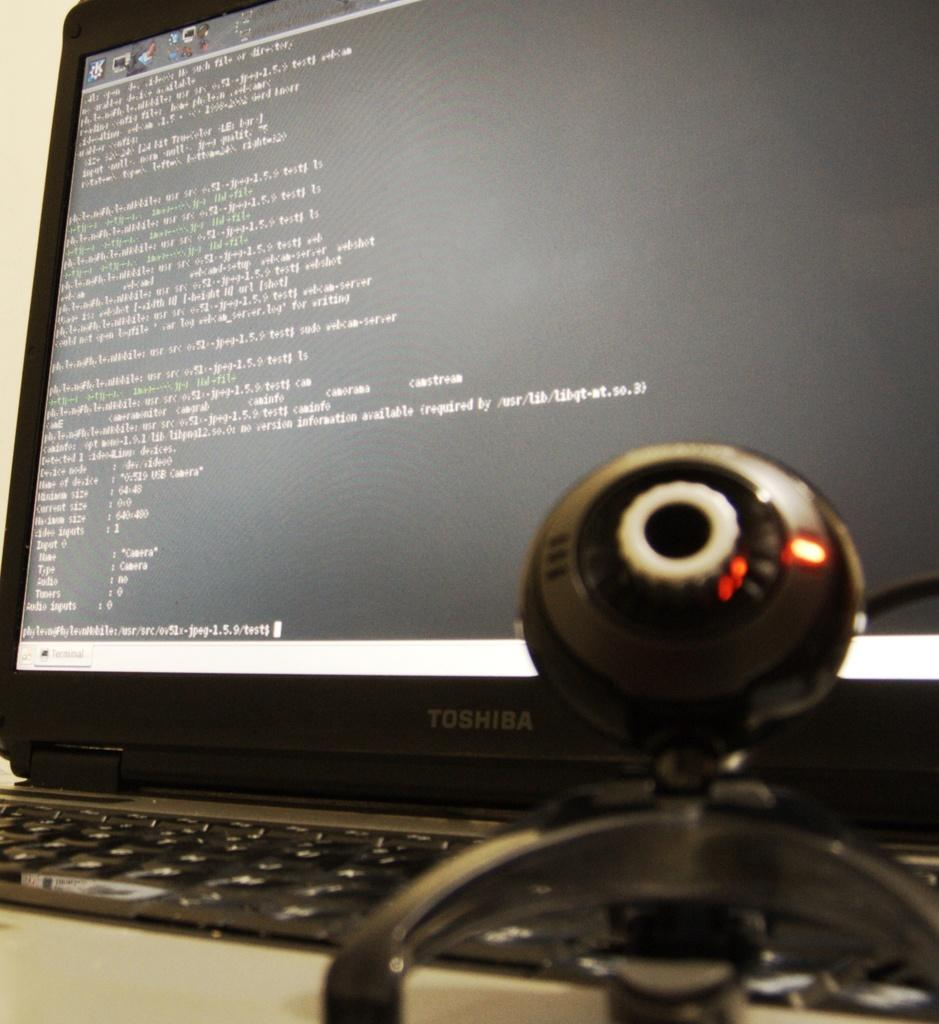<image>
Summarize the visual content of the image. Webcam in front of a black Toshiba monitor. 